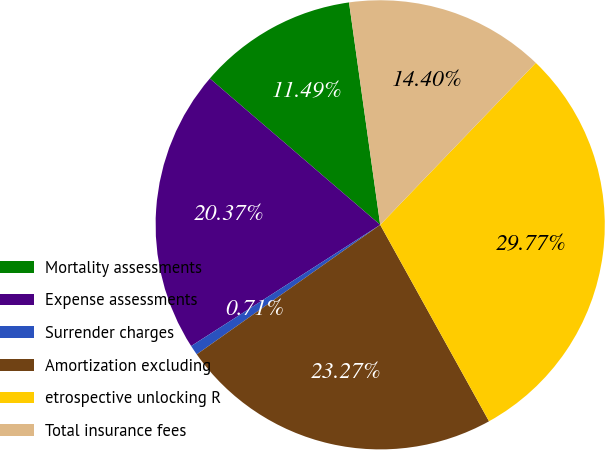Convert chart. <chart><loc_0><loc_0><loc_500><loc_500><pie_chart><fcel>Mortality assessments<fcel>Expense assessments<fcel>Surrender charges<fcel>Amortization excluding<fcel>etrospective unlocking R<fcel>Total insurance fees<nl><fcel>11.49%<fcel>20.37%<fcel>0.71%<fcel>23.27%<fcel>29.77%<fcel>14.4%<nl></chart> 